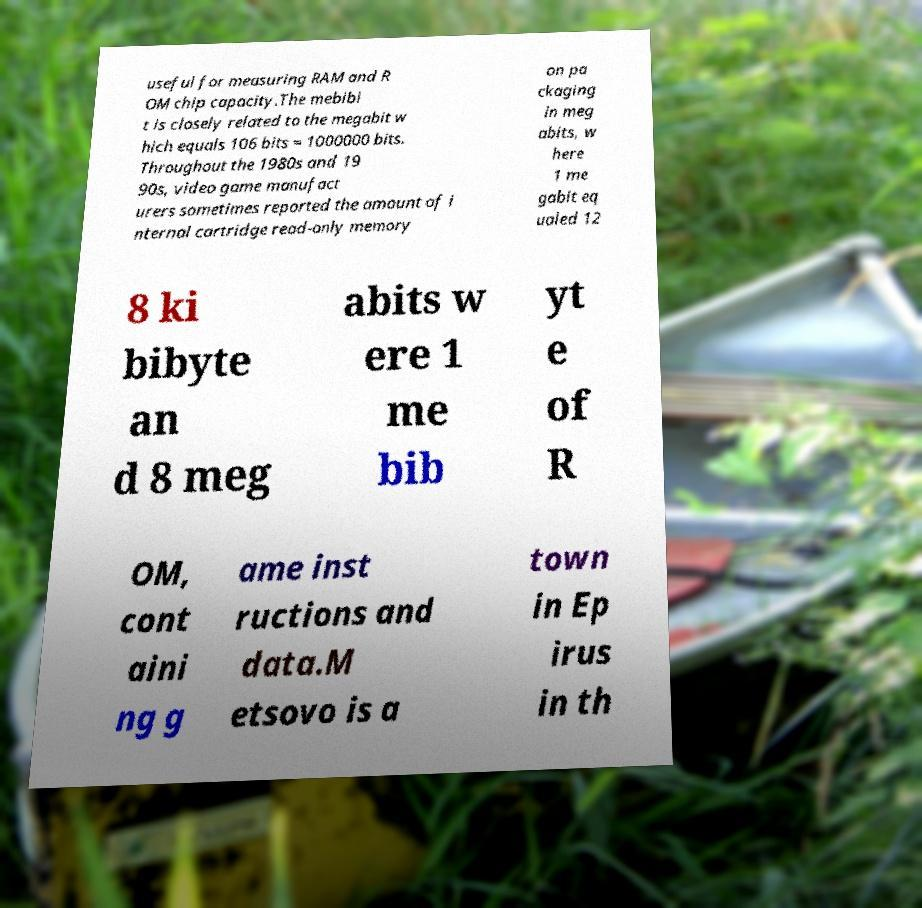What messages or text are displayed in this image? I need them in a readable, typed format. useful for measuring RAM and R OM chip capacity.The mebibi t is closely related to the megabit w hich equals 106 bits = 1000000 bits. Throughout the 1980s and 19 90s, video game manufact urers sometimes reported the amount of i nternal cartridge read-only memory on pa ckaging in meg abits, w here 1 me gabit eq ualed 12 8 ki bibyte an d 8 meg abits w ere 1 me bib yt e of R OM, cont aini ng g ame inst ructions and data.M etsovo is a town in Ep irus in th 